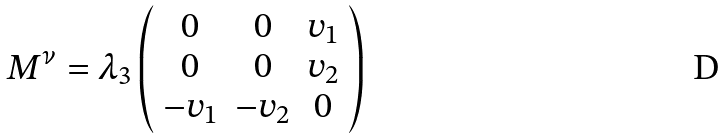<formula> <loc_0><loc_0><loc_500><loc_500>M ^ { \nu } = \lambda _ { 3 } \left ( \begin{array} { c c c } 0 & 0 & v _ { 1 } \\ 0 & 0 & v _ { 2 } \\ - v _ { 1 } & - v _ { 2 } & 0 \end{array} \right )</formula> 